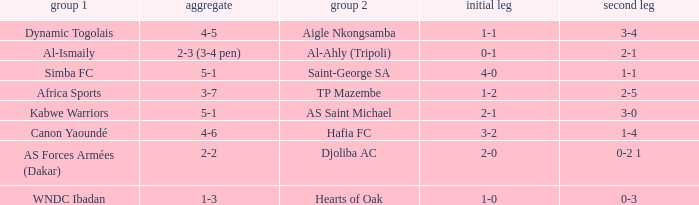When Kabwe Warriors (team 1) played, what was the result of the 1st leg? 2-1. 